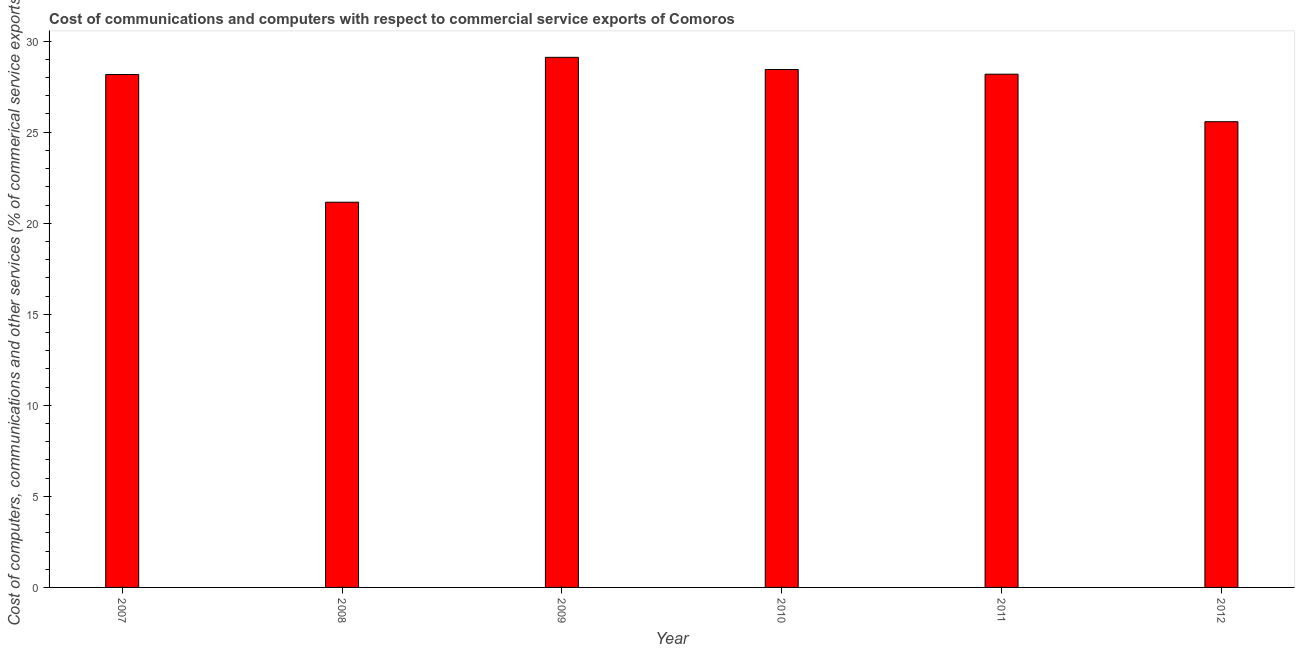Does the graph contain grids?
Your answer should be compact. No. What is the title of the graph?
Provide a short and direct response. Cost of communications and computers with respect to commercial service exports of Comoros. What is the label or title of the Y-axis?
Your answer should be compact. Cost of computers, communications and other services (% of commerical service exports). What is the cost of communications in 2008?
Provide a succinct answer. 21.15. Across all years, what is the maximum cost of communications?
Offer a very short reply. 29.11. Across all years, what is the minimum cost of communications?
Your response must be concise. 21.15. What is the sum of the  computer and other services?
Give a very brief answer. 160.63. What is the difference between the cost of communications in 2008 and 2009?
Offer a very short reply. -7.96. What is the average  computer and other services per year?
Provide a short and direct response. 26.77. What is the median  computer and other services?
Provide a succinct answer. 28.17. In how many years, is the cost of communications greater than 11 %?
Provide a succinct answer. 6. What is the ratio of the  computer and other services in 2009 to that in 2012?
Provide a short and direct response. 1.14. Is the difference between the  computer and other services in 2011 and 2012 greater than the difference between any two years?
Make the answer very short. No. What is the difference between the highest and the second highest  computer and other services?
Offer a terse response. 0.67. What is the difference between the highest and the lowest  computer and other services?
Provide a succinct answer. 7.96. How many bars are there?
Keep it short and to the point. 6. Are all the bars in the graph horizontal?
Offer a terse response. No. How many years are there in the graph?
Offer a terse response. 6. Are the values on the major ticks of Y-axis written in scientific E-notation?
Give a very brief answer. No. What is the Cost of computers, communications and other services (% of commerical service exports) in 2007?
Provide a succinct answer. 28.17. What is the Cost of computers, communications and other services (% of commerical service exports) in 2008?
Offer a very short reply. 21.15. What is the Cost of computers, communications and other services (% of commerical service exports) in 2009?
Provide a succinct answer. 29.11. What is the Cost of computers, communications and other services (% of commerical service exports) of 2010?
Offer a very short reply. 28.44. What is the Cost of computers, communications and other services (% of commerical service exports) of 2011?
Your answer should be compact. 28.18. What is the Cost of computers, communications and other services (% of commerical service exports) of 2012?
Your answer should be very brief. 25.57. What is the difference between the Cost of computers, communications and other services (% of commerical service exports) in 2007 and 2008?
Offer a terse response. 7.01. What is the difference between the Cost of computers, communications and other services (% of commerical service exports) in 2007 and 2009?
Make the answer very short. -0.94. What is the difference between the Cost of computers, communications and other services (% of commerical service exports) in 2007 and 2010?
Your answer should be compact. -0.28. What is the difference between the Cost of computers, communications and other services (% of commerical service exports) in 2007 and 2011?
Ensure brevity in your answer.  -0.02. What is the difference between the Cost of computers, communications and other services (% of commerical service exports) in 2007 and 2012?
Provide a short and direct response. 2.59. What is the difference between the Cost of computers, communications and other services (% of commerical service exports) in 2008 and 2009?
Your response must be concise. -7.96. What is the difference between the Cost of computers, communications and other services (% of commerical service exports) in 2008 and 2010?
Your answer should be very brief. -7.29. What is the difference between the Cost of computers, communications and other services (% of commerical service exports) in 2008 and 2011?
Your answer should be very brief. -7.03. What is the difference between the Cost of computers, communications and other services (% of commerical service exports) in 2008 and 2012?
Provide a short and direct response. -4.42. What is the difference between the Cost of computers, communications and other services (% of commerical service exports) in 2009 and 2010?
Make the answer very short. 0.67. What is the difference between the Cost of computers, communications and other services (% of commerical service exports) in 2009 and 2011?
Your response must be concise. 0.93. What is the difference between the Cost of computers, communications and other services (% of commerical service exports) in 2009 and 2012?
Give a very brief answer. 3.54. What is the difference between the Cost of computers, communications and other services (% of commerical service exports) in 2010 and 2011?
Make the answer very short. 0.26. What is the difference between the Cost of computers, communications and other services (% of commerical service exports) in 2010 and 2012?
Ensure brevity in your answer.  2.87. What is the difference between the Cost of computers, communications and other services (% of commerical service exports) in 2011 and 2012?
Keep it short and to the point. 2.61. What is the ratio of the Cost of computers, communications and other services (% of commerical service exports) in 2007 to that in 2008?
Give a very brief answer. 1.33. What is the ratio of the Cost of computers, communications and other services (% of commerical service exports) in 2007 to that in 2009?
Make the answer very short. 0.97. What is the ratio of the Cost of computers, communications and other services (% of commerical service exports) in 2007 to that in 2012?
Offer a terse response. 1.1. What is the ratio of the Cost of computers, communications and other services (% of commerical service exports) in 2008 to that in 2009?
Your response must be concise. 0.73. What is the ratio of the Cost of computers, communications and other services (% of commerical service exports) in 2008 to that in 2010?
Offer a terse response. 0.74. What is the ratio of the Cost of computers, communications and other services (% of commerical service exports) in 2008 to that in 2011?
Your answer should be very brief. 0.75. What is the ratio of the Cost of computers, communications and other services (% of commerical service exports) in 2008 to that in 2012?
Ensure brevity in your answer.  0.83. What is the ratio of the Cost of computers, communications and other services (% of commerical service exports) in 2009 to that in 2011?
Provide a succinct answer. 1.03. What is the ratio of the Cost of computers, communications and other services (% of commerical service exports) in 2009 to that in 2012?
Your answer should be very brief. 1.14. What is the ratio of the Cost of computers, communications and other services (% of commerical service exports) in 2010 to that in 2012?
Provide a succinct answer. 1.11. What is the ratio of the Cost of computers, communications and other services (% of commerical service exports) in 2011 to that in 2012?
Keep it short and to the point. 1.1. 